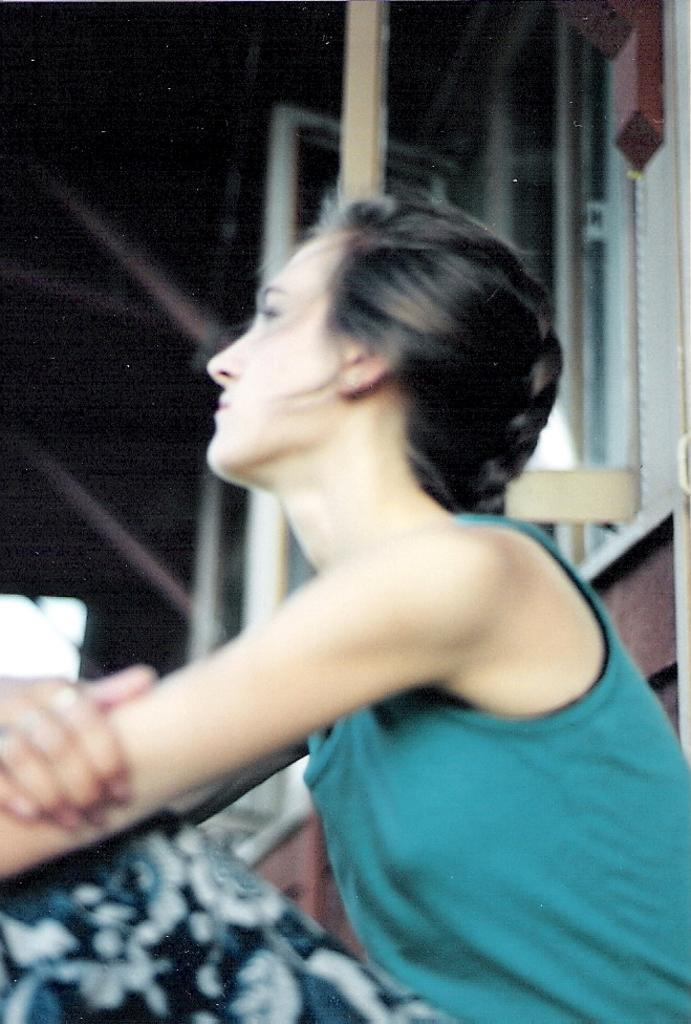What is the main subject in the center of the image? There is a woman sitting in the center of the image. What can be seen in the background of the image? There is a window visible in the background. What part of the building is visible in the image? The roof is visible in the image. What is the name of the woman's knee in the image? There is no mention of a knee or a name in the image, so this question cannot be answered definitively. 